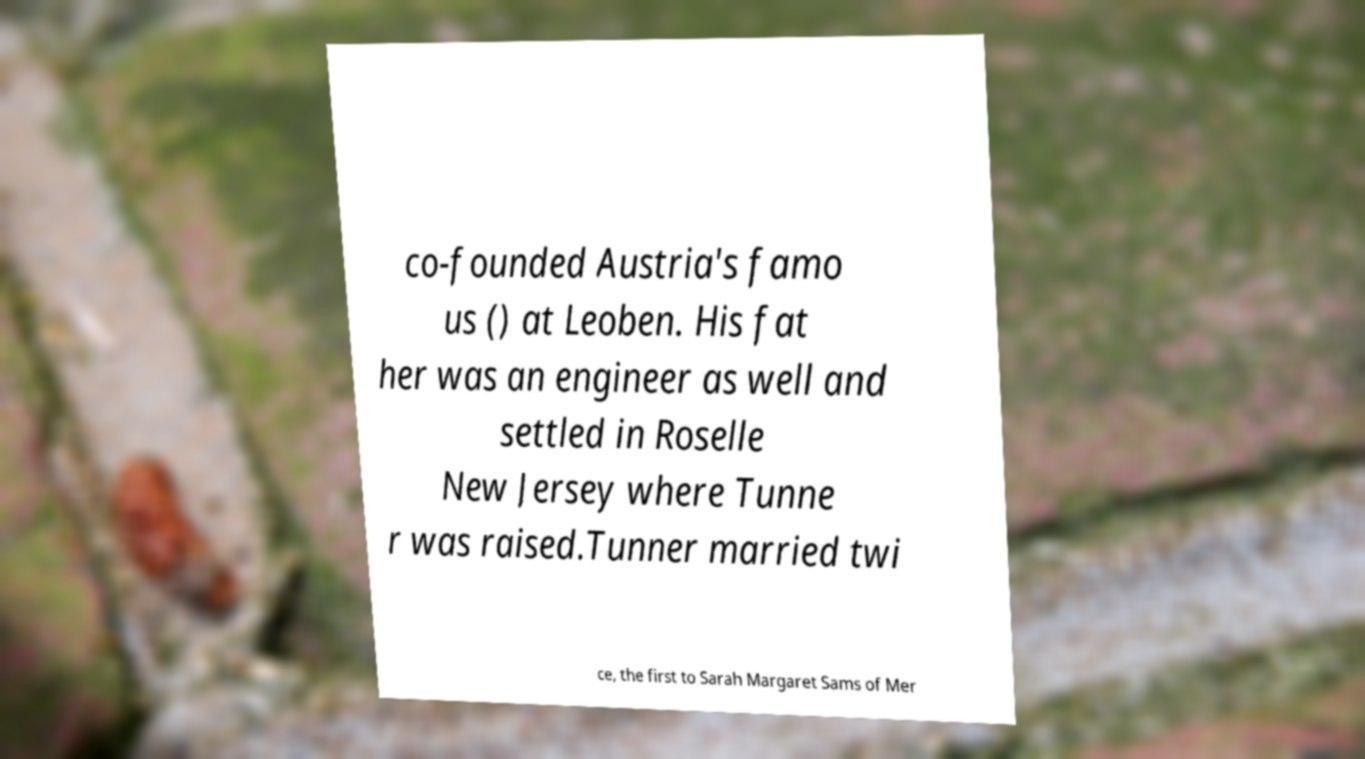For documentation purposes, I need the text within this image transcribed. Could you provide that? co-founded Austria's famo us () at Leoben. His fat her was an engineer as well and settled in Roselle New Jersey where Tunne r was raised.Tunner married twi ce, the first to Sarah Margaret Sams of Mer 